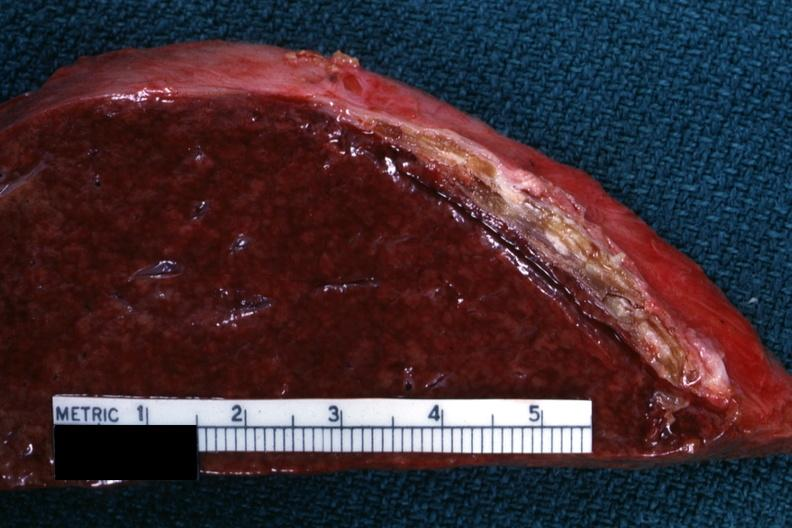what is present?
Answer the question using a single word or phrase. Sugar coated 